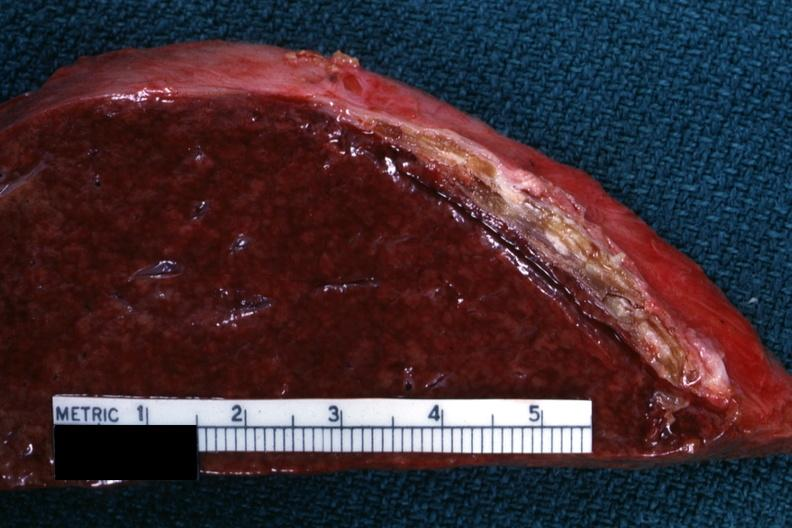what is present?
Answer the question using a single word or phrase. Sugar coated 